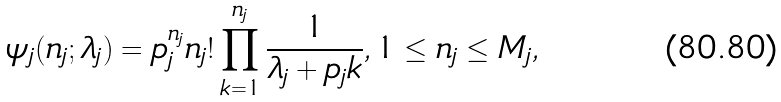<formula> <loc_0><loc_0><loc_500><loc_500>\psi _ { j } ( n _ { j } ; \lambda _ { j } ) = p _ { j } ^ { n _ { j } } n _ { j } ! \prod _ { k = 1 } ^ { n _ { j } } \frac { 1 } { \lambda _ { j } + p _ { j } k } , 1 \leq n _ { j } \leq M _ { j } ,</formula> 